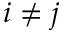<formula> <loc_0><loc_0><loc_500><loc_500>i \neq j</formula> 